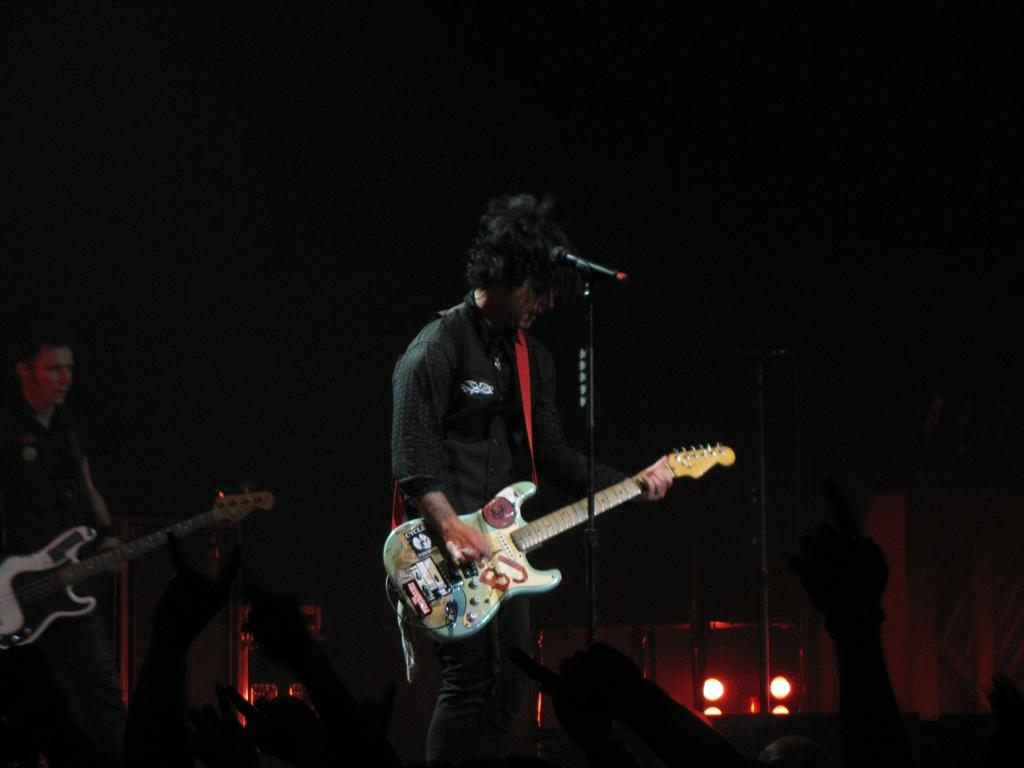What is the man in the image doing? The man is standing and playing a guitar in the image. Can you describe the other person in the image? There is another person standing in the background, and they are also playing a guitar. How many people are playing guitars in the image? Both the man in the foreground and the person in the background are playing guitars, so there are two people playing guitars in the image. What type of glue is being used to attach the veil to the roof in the image? There is no glue, veil, or roof present in the image; it features two people playing guitars. 